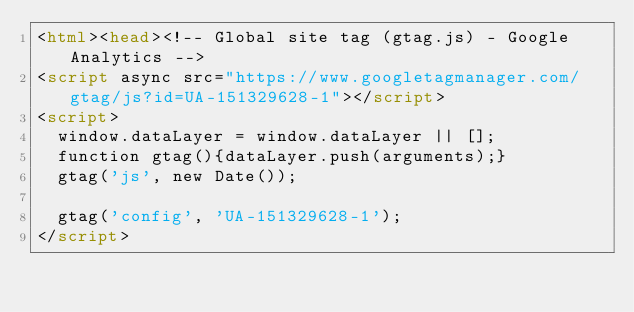<code> <loc_0><loc_0><loc_500><loc_500><_HTML_><html><head><!-- Global site tag (gtag.js) - Google Analytics -->
<script async src="https://www.googletagmanager.com/gtag/js?id=UA-151329628-1"></script>
<script>
  window.dataLayer = window.dataLayer || [];
  function gtag(){dataLayer.push(arguments);}
  gtag('js', new Date());

  gtag('config', 'UA-151329628-1');
</script></code> 